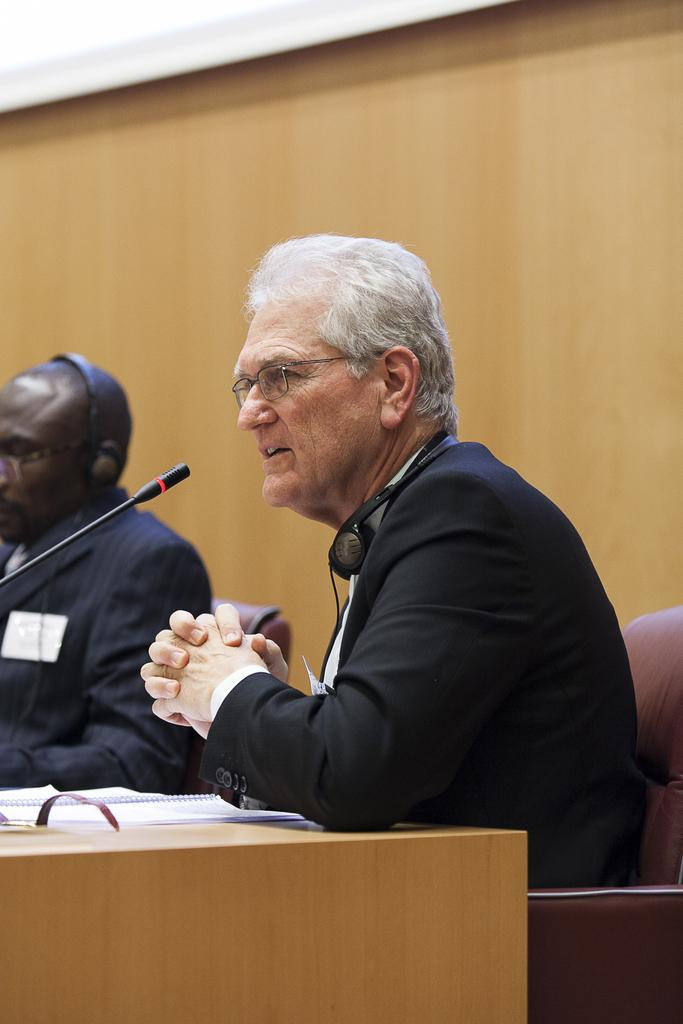How many people are seated in the image? There are two men seated in the image. What are the men sitting on? The men are seated on chairs. What is the man with the microphone doing? The man with the microphone is speaking. What can be seen on the table in the image? There are papers on the table. What type of pan is being used to cook food in the image? There is no pan or cooking activity present in the image. What tax-related information can be found on the papers in the image? The provided facts do not mention any tax-related information on the papers in the image. 